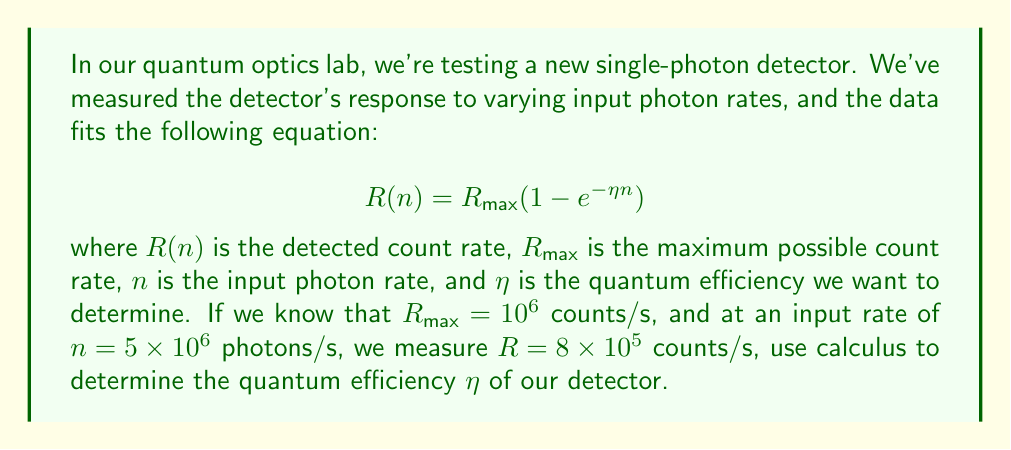Could you help me with this problem? Let's approach this step-by-step:

1) We're given the equation: $$R(n) = R_{\text{max}}(1 - e^{-\eta n})$$

2) We know the following values:
   $R_{\text{max}} = 10^6$ counts/s
   $n = 5 \times 10^6$ photons/s
   $R = 8 \times 10^5$ counts/s

3) Let's substitute these values into the equation:

   $$8 \times 10^5 = 10^6(1 - e^{-\eta (5 \times 10^6)})$$

4) Dividing both sides by $10^6$:

   $$0.8 = 1 - e^{-5\eta \times 10^6}$$

5) Subtracting both sides from 1:

   $$0.2 = e^{-5\eta \times 10^6}$$

6) Now, let's take the natural logarithm of both sides:

   $$\ln(0.2) = -5\eta \times 10^6$$

7) Solving for $\eta$:

   $$\eta = -\frac{\ln(0.2)}{5 \times 10^6}$$

8) Calculate the final value:

   $$\eta = -\frac{-1.60943...}{5 \times 10^6} \approx 3.22 \times 10^{-7}$$

This method uses the properties of logarithms, which are closely related to calculus. The natural logarithm is the inverse function of the exponential function, and its derivative is $\frac{1}{x}$, which is a fundamental concept in calculus.
Answer: $\eta \approx 3.22 \times 10^{-7}$ 